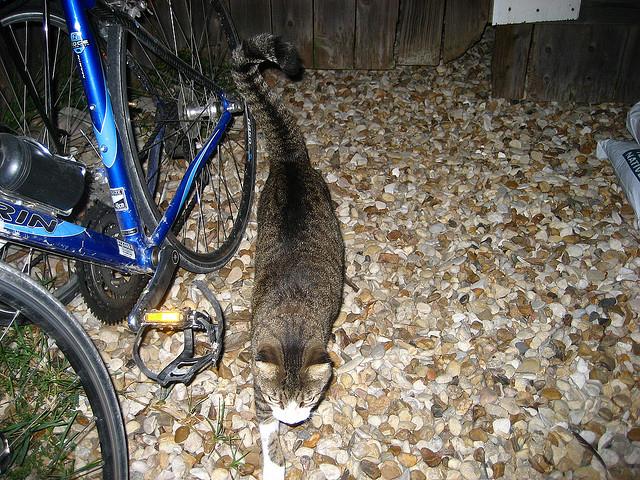Does the bike have a flat tire?
Concise answer only. No. What is shown on the left side of the picture?
Keep it brief. Bike. Is the cat standing on grass?
Short answer required. No. 